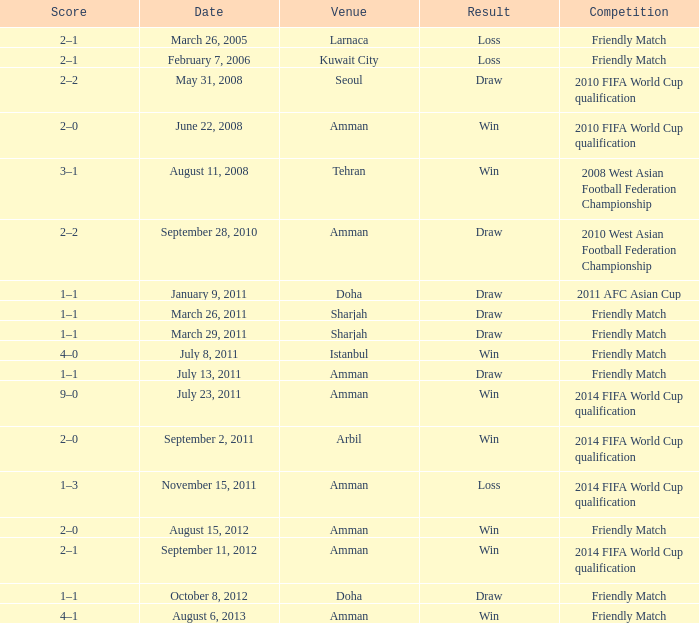What was the name of the competition that took place on may 31, 2008? 2010 FIFA World Cup qualification. 